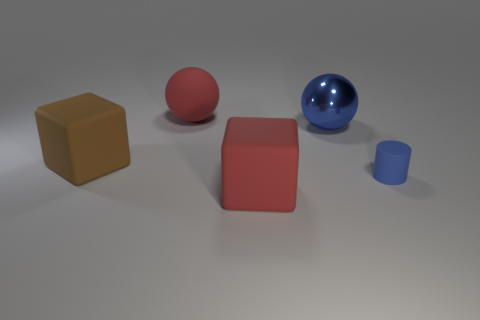How many blue things are either large rubber things or shiny balls?
Your answer should be compact. 1. How big is the red object behind the big block behind the large red thing in front of the large matte sphere?
Make the answer very short. Large. There is a red matte object that is the same shape as the brown rubber thing; what size is it?
Keep it short and to the point. Large. How many tiny objects are brown rubber objects or balls?
Keep it short and to the point. 0. Is the material of the red object behind the tiny blue thing the same as the cube that is in front of the small matte thing?
Make the answer very short. Yes. There is a object right of the metallic object; what is it made of?
Your response must be concise. Rubber. What number of matte things are either blue things or big spheres?
Your answer should be compact. 2. What color is the cube behind the large red thing in front of the small blue cylinder?
Your response must be concise. Brown. Is the red cube made of the same material as the blue object behind the brown matte thing?
Give a very brief answer. No. What is the color of the matte cube that is left of the large red rubber thing in front of the large red object that is behind the small blue rubber cylinder?
Provide a short and direct response. Brown. 